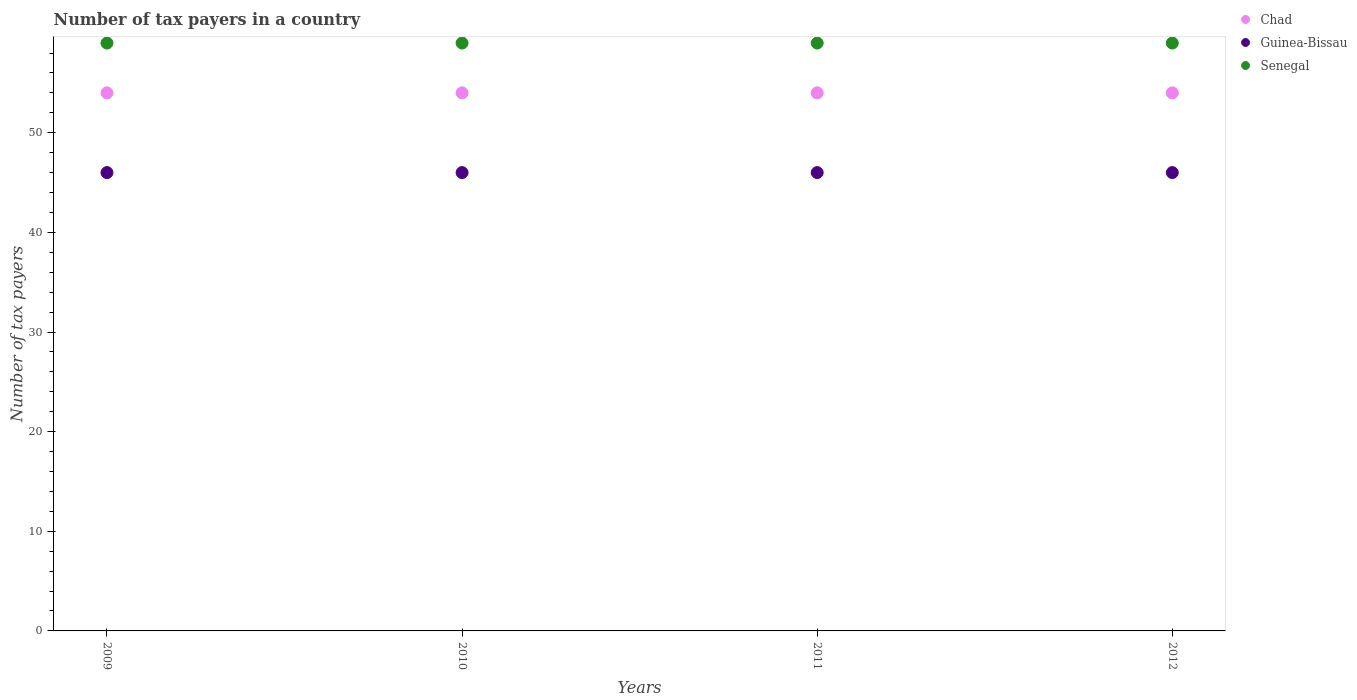Is the number of dotlines equal to the number of legend labels?
Give a very brief answer. Yes. What is the number of tax payers in in Senegal in 2012?
Ensure brevity in your answer.  59. Across all years, what is the maximum number of tax payers in in Senegal?
Your response must be concise. 59. Across all years, what is the minimum number of tax payers in in Chad?
Give a very brief answer. 54. In which year was the number of tax payers in in Chad maximum?
Ensure brevity in your answer.  2009. In which year was the number of tax payers in in Chad minimum?
Ensure brevity in your answer.  2009. What is the total number of tax payers in in Senegal in the graph?
Your answer should be compact. 236. What is the difference between the number of tax payers in in Guinea-Bissau in 2010 and that in 2012?
Make the answer very short. 0. What is the difference between the number of tax payers in in Chad in 2011 and the number of tax payers in in Guinea-Bissau in 2010?
Give a very brief answer. 8. What is the average number of tax payers in in Chad per year?
Your answer should be compact. 54. In the year 2009, what is the difference between the number of tax payers in in Chad and number of tax payers in in Guinea-Bissau?
Offer a terse response. 8. Is the difference between the number of tax payers in in Chad in 2010 and 2011 greater than the difference between the number of tax payers in in Guinea-Bissau in 2010 and 2011?
Ensure brevity in your answer.  No. What is the difference between the highest and the second highest number of tax payers in in Senegal?
Offer a terse response. 0. In how many years, is the number of tax payers in in Senegal greater than the average number of tax payers in in Senegal taken over all years?
Keep it short and to the point. 0. Is the sum of the number of tax payers in in Senegal in 2011 and 2012 greater than the maximum number of tax payers in in Chad across all years?
Your answer should be very brief. Yes. Is it the case that in every year, the sum of the number of tax payers in in Guinea-Bissau and number of tax payers in in Chad  is greater than the number of tax payers in in Senegal?
Your response must be concise. Yes. Does the number of tax payers in in Guinea-Bissau monotonically increase over the years?
Provide a succinct answer. No. Is the number of tax payers in in Senegal strictly greater than the number of tax payers in in Chad over the years?
Offer a terse response. Yes. How many dotlines are there?
Make the answer very short. 3. Are the values on the major ticks of Y-axis written in scientific E-notation?
Ensure brevity in your answer.  No. How many legend labels are there?
Your answer should be very brief. 3. How are the legend labels stacked?
Ensure brevity in your answer.  Vertical. What is the title of the graph?
Give a very brief answer. Number of tax payers in a country. Does "Portugal" appear as one of the legend labels in the graph?
Provide a short and direct response. No. What is the label or title of the X-axis?
Keep it short and to the point. Years. What is the label or title of the Y-axis?
Your answer should be very brief. Number of tax payers. What is the Number of tax payers of Chad in 2009?
Offer a very short reply. 54. What is the Number of tax payers of Guinea-Bissau in 2009?
Keep it short and to the point. 46. What is the Number of tax payers in Chad in 2011?
Your answer should be compact. 54. What is the Number of tax payers in Senegal in 2011?
Ensure brevity in your answer.  59. What is the Number of tax payers in Chad in 2012?
Make the answer very short. 54. Across all years, what is the maximum Number of tax payers of Chad?
Offer a terse response. 54. Across all years, what is the maximum Number of tax payers of Guinea-Bissau?
Ensure brevity in your answer.  46. Across all years, what is the minimum Number of tax payers in Guinea-Bissau?
Offer a very short reply. 46. Across all years, what is the minimum Number of tax payers in Senegal?
Keep it short and to the point. 59. What is the total Number of tax payers of Chad in the graph?
Offer a terse response. 216. What is the total Number of tax payers in Guinea-Bissau in the graph?
Make the answer very short. 184. What is the total Number of tax payers of Senegal in the graph?
Ensure brevity in your answer.  236. What is the difference between the Number of tax payers of Chad in 2009 and that in 2010?
Give a very brief answer. 0. What is the difference between the Number of tax payers in Senegal in 2009 and that in 2010?
Provide a succinct answer. 0. What is the difference between the Number of tax payers of Guinea-Bissau in 2009 and that in 2011?
Your answer should be compact. 0. What is the difference between the Number of tax payers in Guinea-Bissau in 2010 and that in 2011?
Provide a succinct answer. 0. What is the difference between the Number of tax payers of Senegal in 2010 and that in 2011?
Make the answer very short. 0. What is the difference between the Number of tax payers in Chad in 2011 and that in 2012?
Your response must be concise. 0. What is the difference between the Number of tax payers of Guinea-Bissau in 2009 and the Number of tax payers of Senegal in 2010?
Your answer should be compact. -13. What is the difference between the Number of tax payers of Chad in 2009 and the Number of tax payers of Guinea-Bissau in 2011?
Offer a terse response. 8. What is the difference between the Number of tax payers of Chad in 2009 and the Number of tax payers of Guinea-Bissau in 2012?
Your response must be concise. 8. What is the difference between the Number of tax payers in Chad in 2010 and the Number of tax payers in Guinea-Bissau in 2011?
Keep it short and to the point. 8. What is the difference between the Number of tax payers of Chad in 2010 and the Number of tax payers of Senegal in 2011?
Ensure brevity in your answer.  -5. What is the difference between the Number of tax payers of Chad in 2011 and the Number of tax payers of Senegal in 2012?
Your response must be concise. -5. What is the average Number of tax payers in Guinea-Bissau per year?
Offer a terse response. 46. What is the average Number of tax payers in Senegal per year?
Your answer should be very brief. 59. In the year 2009, what is the difference between the Number of tax payers of Chad and Number of tax payers of Guinea-Bissau?
Make the answer very short. 8. In the year 2009, what is the difference between the Number of tax payers in Chad and Number of tax payers in Senegal?
Give a very brief answer. -5. In the year 2009, what is the difference between the Number of tax payers of Guinea-Bissau and Number of tax payers of Senegal?
Offer a terse response. -13. In the year 2010, what is the difference between the Number of tax payers of Guinea-Bissau and Number of tax payers of Senegal?
Offer a very short reply. -13. In the year 2011, what is the difference between the Number of tax payers of Chad and Number of tax payers of Guinea-Bissau?
Give a very brief answer. 8. In the year 2011, what is the difference between the Number of tax payers of Chad and Number of tax payers of Senegal?
Your answer should be compact. -5. In the year 2012, what is the difference between the Number of tax payers of Chad and Number of tax payers of Guinea-Bissau?
Keep it short and to the point. 8. In the year 2012, what is the difference between the Number of tax payers of Chad and Number of tax payers of Senegal?
Ensure brevity in your answer.  -5. What is the ratio of the Number of tax payers of Chad in 2009 to that in 2010?
Offer a terse response. 1. What is the ratio of the Number of tax payers in Guinea-Bissau in 2009 to that in 2010?
Ensure brevity in your answer.  1. What is the ratio of the Number of tax payers in Chad in 2009 to that in 2011?
Keep it short and to the point. 1. What is the ratio of the Number of tax payers in Guinea-Bissau in 2009 to that in 2011?
Provide a short and direct response. 1. What is the ratio of the Number of tax payers in Senegal in 2009 to that in 2012?
Provide a succinct answer. 1. What is the ratio of the Number of tax payers in Chad in 2010 to that in 2012?
Offer a terse response. 1. What is the ratio of the Number of tax payers in Chad in 2011 to that in 2012?
Provide a succinct answer. 1. What is the ratio of the Number of tax payers in Guinea-Bissau in 2011 to that in 2012?
Make the answer very short. 1. What is the ratio of the Number of tax payers of Senegal in 2011 to that in 2012?
Provide a short and direct response. 1. What is the difference between the highest and the second highest Number of tax payers of Chad?
Make the answer very short. 0. What is the difference between the highest and the second highest Number of tax payers in Senegal?
Your answer should be very brief. 0. What is the difference between the highest and the lowest Number of tax payers in Senegal?
Your response must be concise. 0. 